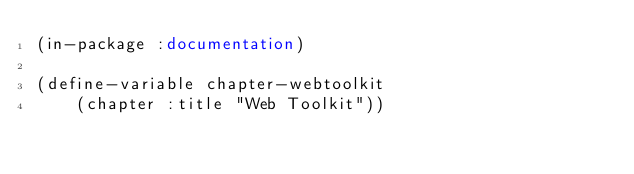<code> <loc_0><loc_0><loc_500><loc_500><_Lisp_>(in-package :documentation)

(define-variable chapter-webtoolkit
    (chapter :title "Web Toolkit"))
</code> 